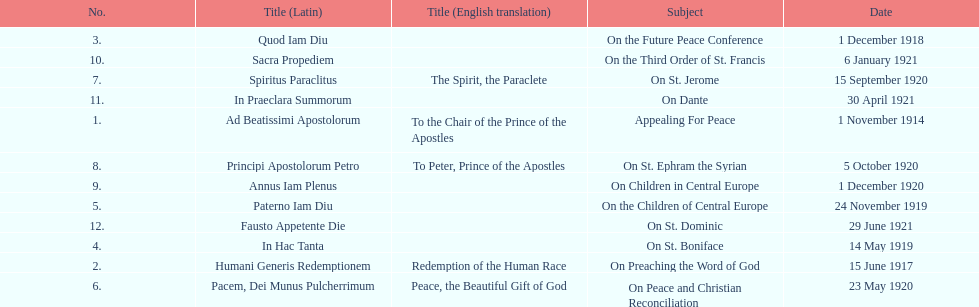What is the first english translation listed on the table? To the Chair of the Prince of the Apostles. 